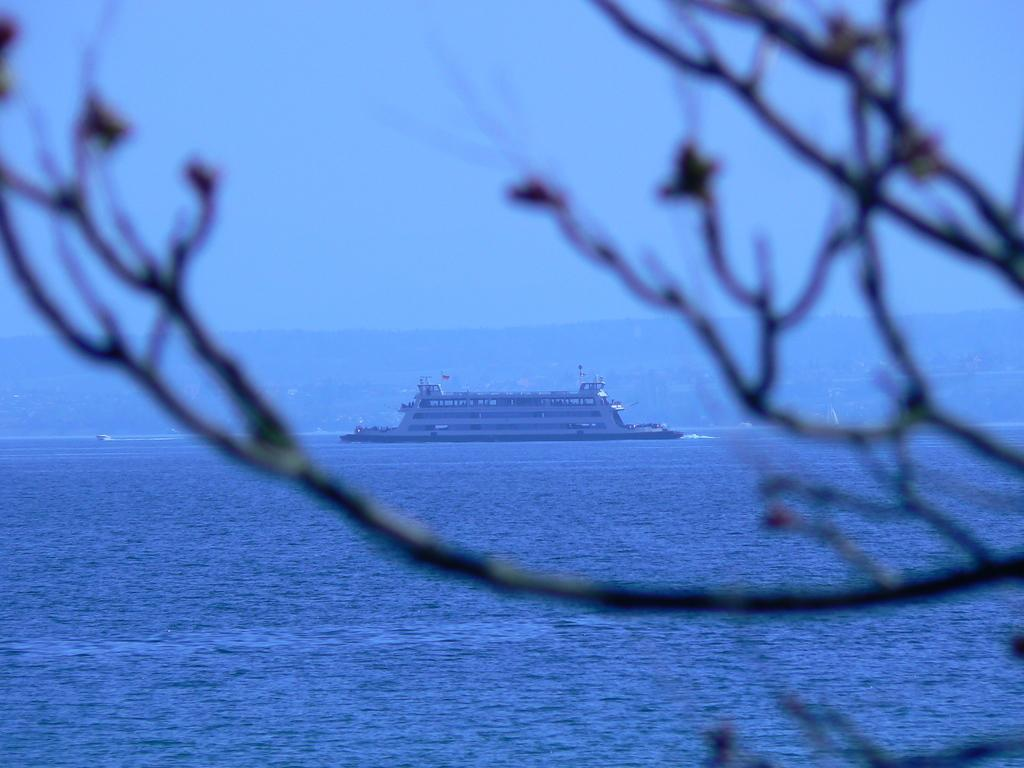What is the main subject of the image? There is a huge ship in the center of the image. Where is the ship located? The ship is on the water. What can be seen in the background of the image? There are trees visible in the image. What type of glove can be seen on the ship's owner in the image? There is no glove or ship's owner present in the image. What is the taste of the water surrounding the ship in the image? The taste of the water cannot be determined from the image. 